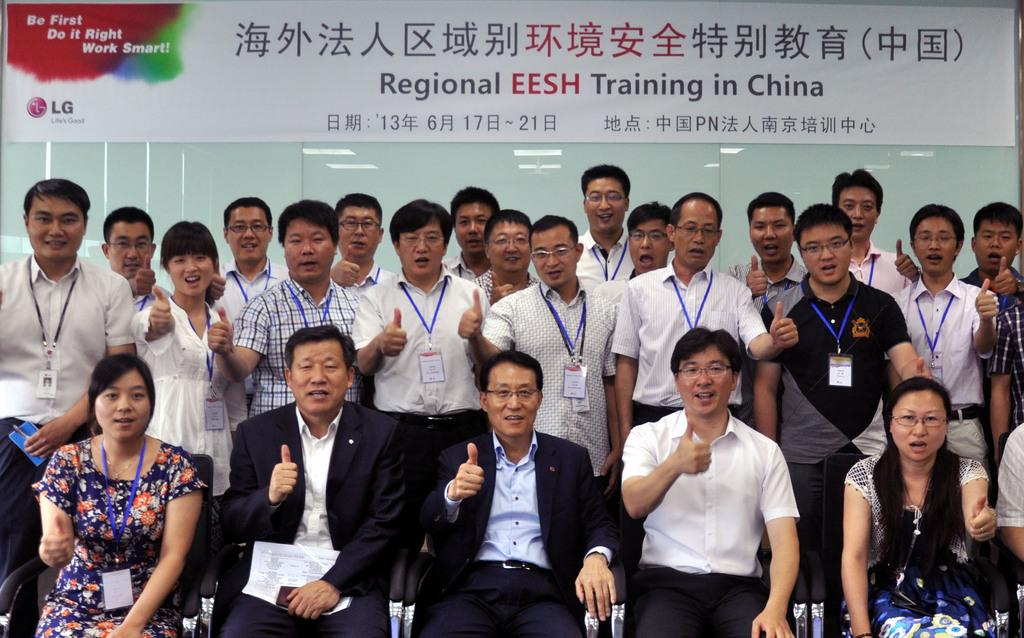What are the people in the image doing? There are people sitting on chairs and standing in the image. What can be seen in the background of the image? There is a poster and lights in the background of the image. How many stars can be seen in the image? There are no stars visible in the image. Are there any brothers in the image? The provided facts do not mention any brothers, so we cannot determine if there are any in the image. 